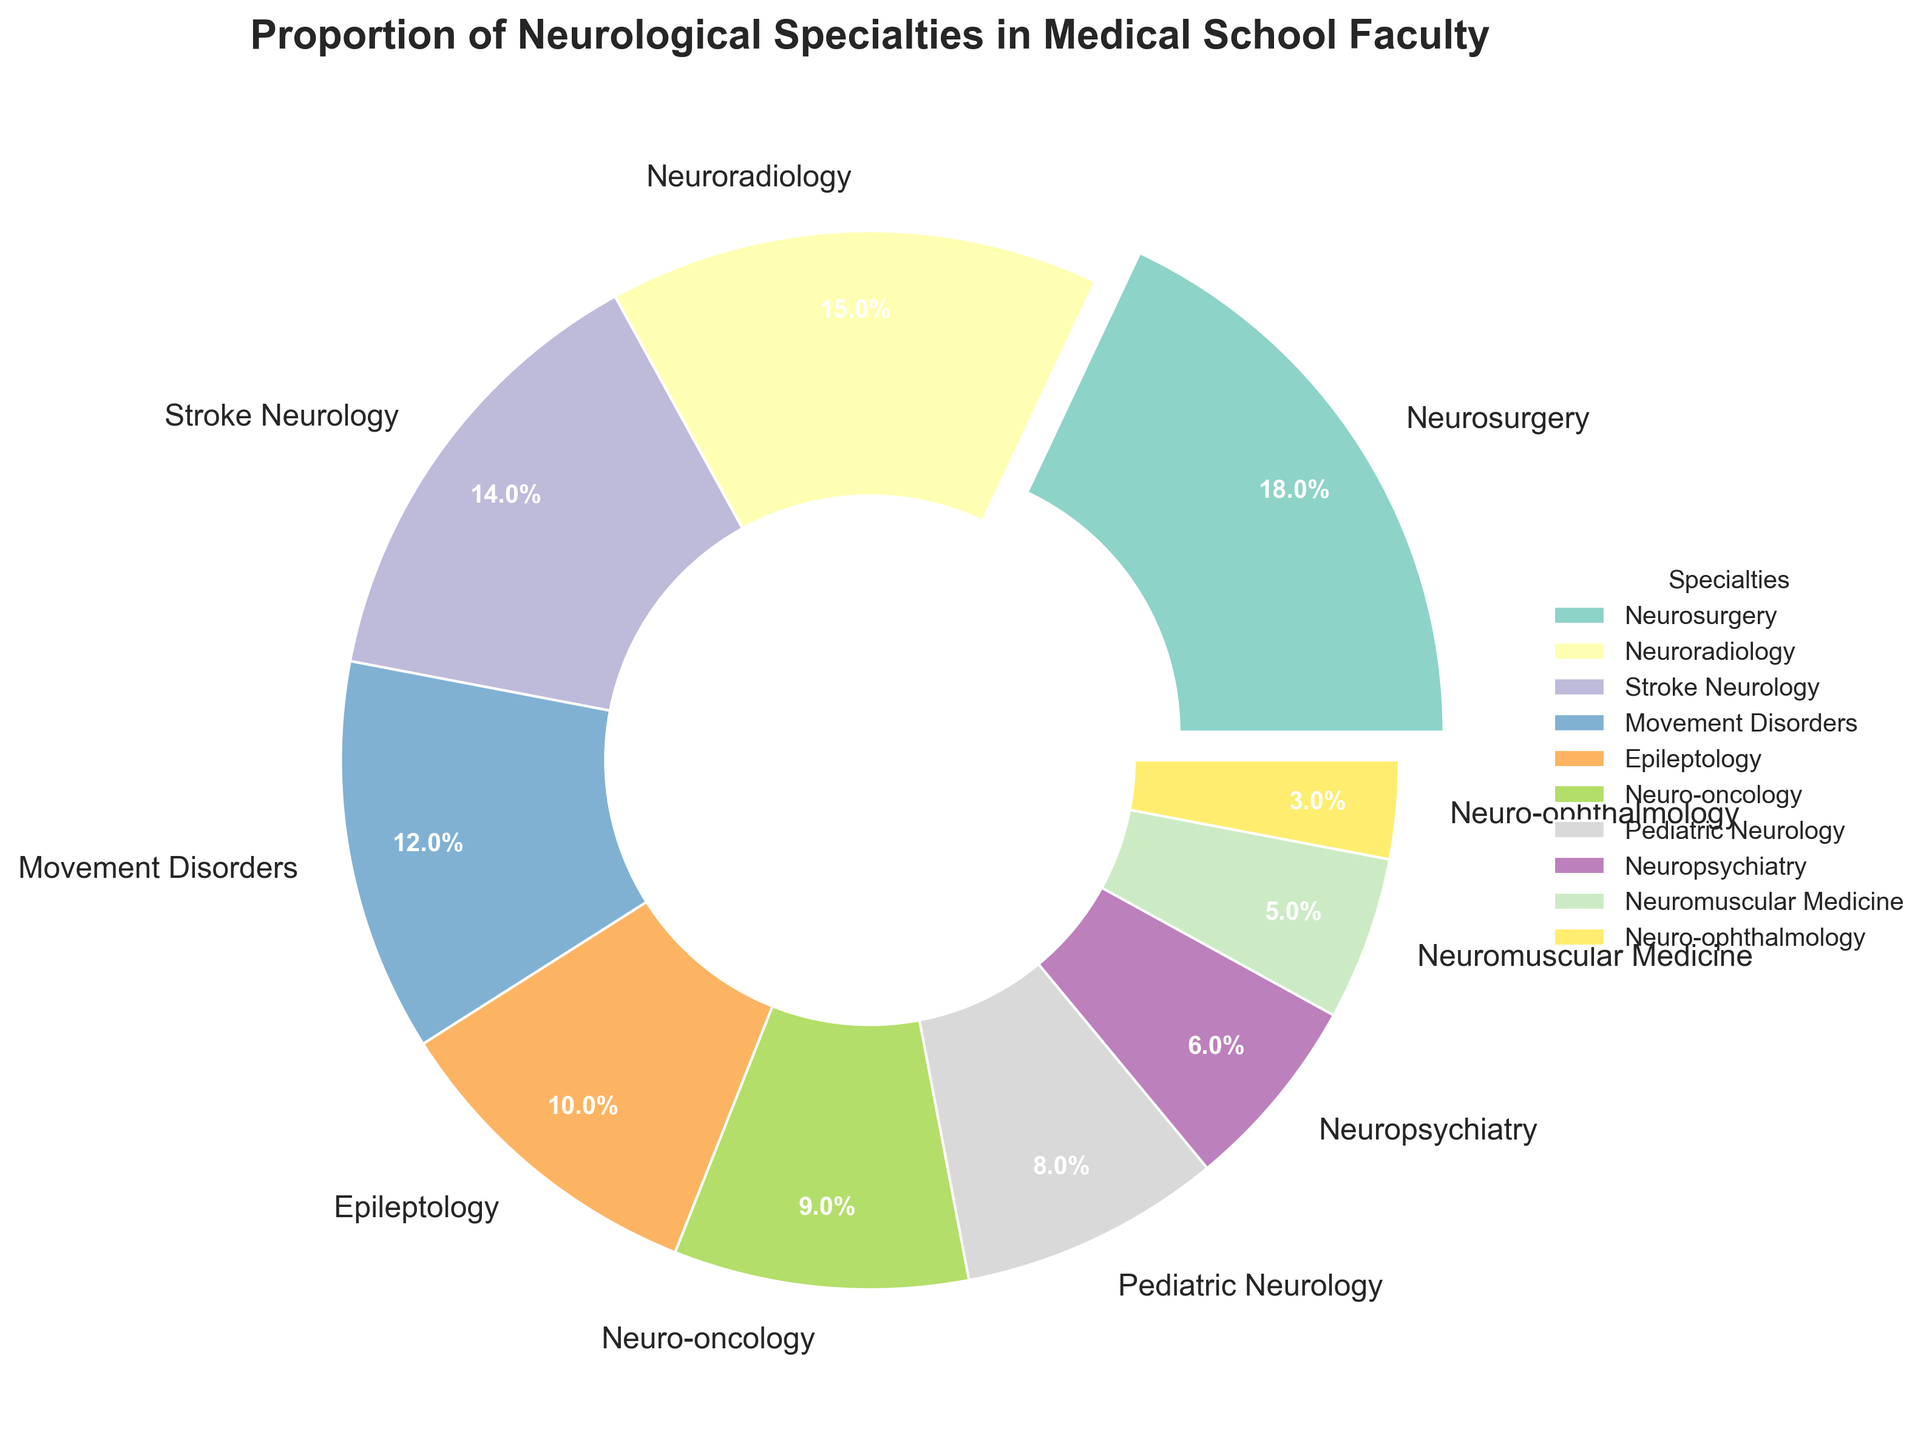What proportion of the faculty is involved in Neurosurgery? The slice representing Neurosurgery is clearly labeled with its percentage. By looking at the pie chart, you can see the percentage for Neurosurgery.
Answer: 18% Which specialty has the smallest representation in the faculty? Identify the smallest wedge in the pie chart and read the corresponding specialty label.
Answer: Neuro-ophthalmology What is the combined percentage of Neuroradiology, Stroke Neurology, and Movement Disorders? Sum the percentages of Neuroradiology (15%), Stroke Neurology (14%), and Movement Disorders (12%) as shown on the chart.
Answer: 41% How much larger is the proportion of Neuro-oncology compared to Neuro-ophthalmology? Subtract the percentage of Neuro-ophthalmology (3%) from that of Neuro-oncology (9%) to find the difference.
Answer: 6% Which specialties together make up more than 50% of the faculty? Sum the percentages starting from the largest until the total exceeds 50%. Here, start with Neurosurgery (18%), Neuroradiology (15%), Stroke Neurology (14%), and Movement Disorders (12%). Their combined total is 18+15+14+12=59%, exceeding 50%.
Answer: Neurosurgery, Neuroradiology, Stroke Neurology, Movement Disorders Which specialty has the second largest representation? By identifying the largest wedges in the chart, it is clear from the labels that after Neurosurgery (18%), Neuroradiology (15%) has the next largest percentage.
Answer: Neuroradiology What is the proportion difference between Pediatric Neurology and Neuromuscular Medicine? Subtract the percentage of Neuromuscular Medicine (5%) from that of Pediatric Neurology (8%) to find the difference.
Answer: 3% What color in the pie chart represents the specialty with the largest proportion? Find the largest wedge which represents Neurosurgery and identify its color from the chart.
Answer: The color associated with Neurosurgery over the chart Which specialties are represented by wedges exploding outwards in the pie chart? Exploding wedges (slightly pulled out) indicate special emphasis. Only the specialty with the highest proportion (Neurosurgery) is exploded outward.
Answer: Neurosurgery 